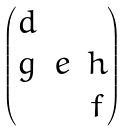<formula> <loc_0><loc_0><loc_500><loc_500>\begin{pmatrix} d & & \\ g & e & h \\ & & f \end{pmatrix}</formula> 